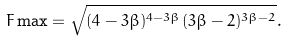Convert formula to latex. <formula><loc_0><loc_0><loc_500><loc_500>F \max = \sqrt { ( 4 - 3 \beta ) ^ { 4 - 3 \beta } ( 3 \beta - 2 ) ^ { 3 \beta - 2 } } .</formula> 